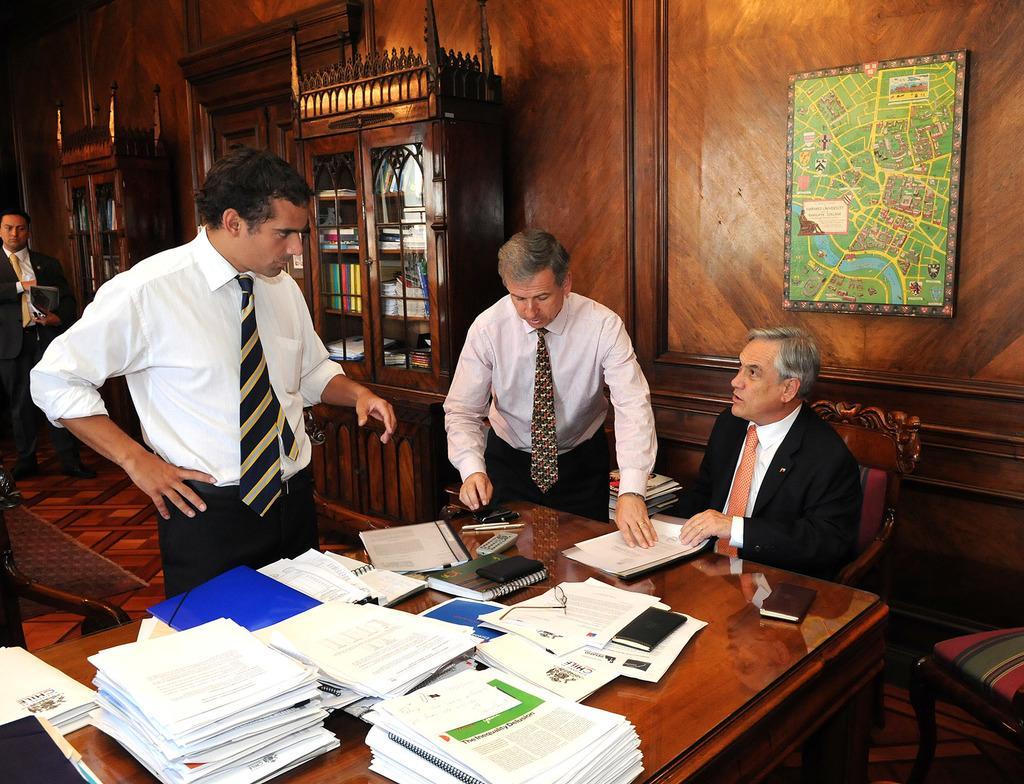In one or two sentences, can you explain what this image depicts? There are three men standing and a person sitting on the chair. I can see the papers, books, remote, pens, files and few other things are placed on the table. This is a frame, which is attached to the wall. I think these are the cupboards with books and few other things in it. This looks like a wooden door. On the right side of the image, I can see another chair. I think this wall is of the wooden texture. Here is the floor. 